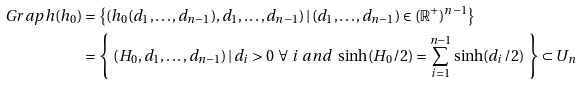<formula> <loc_0><loc_0><loc_500><loc_500>G r a p h ( h _ { 0 } ) & = \left \{ ( h _ { 0 } ( d _ { 1 } , \hdots , d _ { n - 1 } ) , d _ { 1 } , \hdots , d _ { n - 1 } ) \, | \, ( d _ { 1 } , \hdots , d _ { n - 1 } ) \in ( \mathbb { R } ^ { + } ) ^ { n - 1 } \right \} \\ & = \left \{ \ ( H _ { 0 } , d _ { 1 } , \hdots , d _ { n - 1 } ) \, | \, d _ { i } > 0 \ \forall \ i \ a n d \ \sinh ( H _ { 0 } / 2 ) = \sum _ { i = 1 } ^ { n - 1 } \sinh ( d _ { i } / 2 ) \ \right \} \subset U _ { n }</formula> 